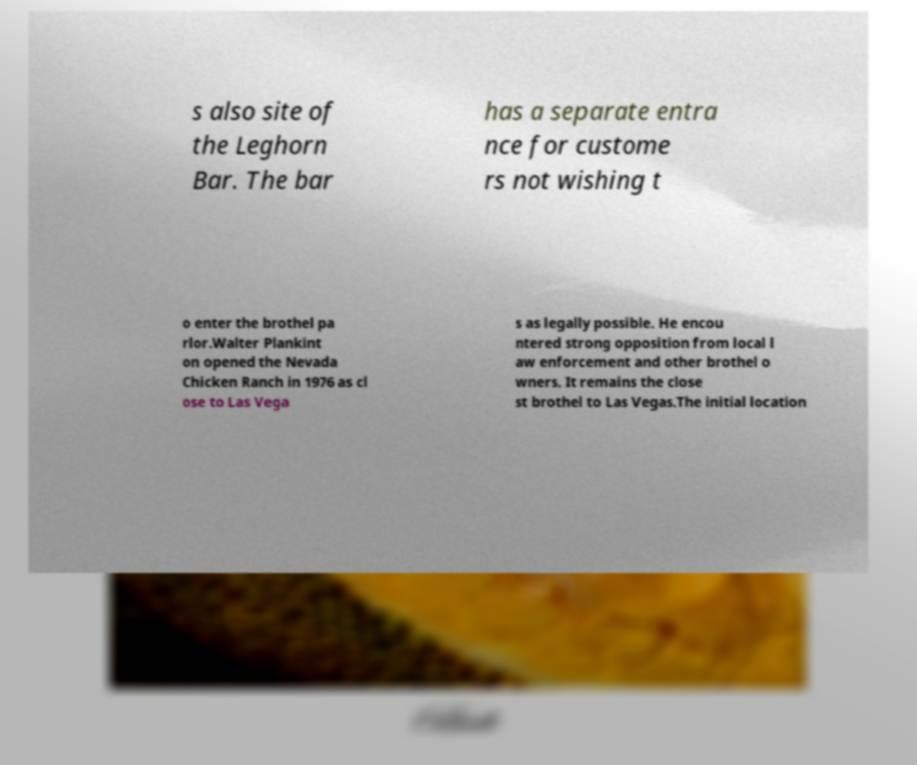What messages or text are displayed in this image? I need them in a readable, typed format. s also site of the Leghorn Bar. The bar has a separate entra nce for custome rs not wishing t o enter the brothel pa rlor.Walter Plankint on opened the Nevada Chicken Ranch in 1976 as cl ose to Las Vega s as legally possible. He encou ntered strong opposition from local l aw enforcement and other brothel o wners. It remains the close st brothel to Las Vegas.The initial location 